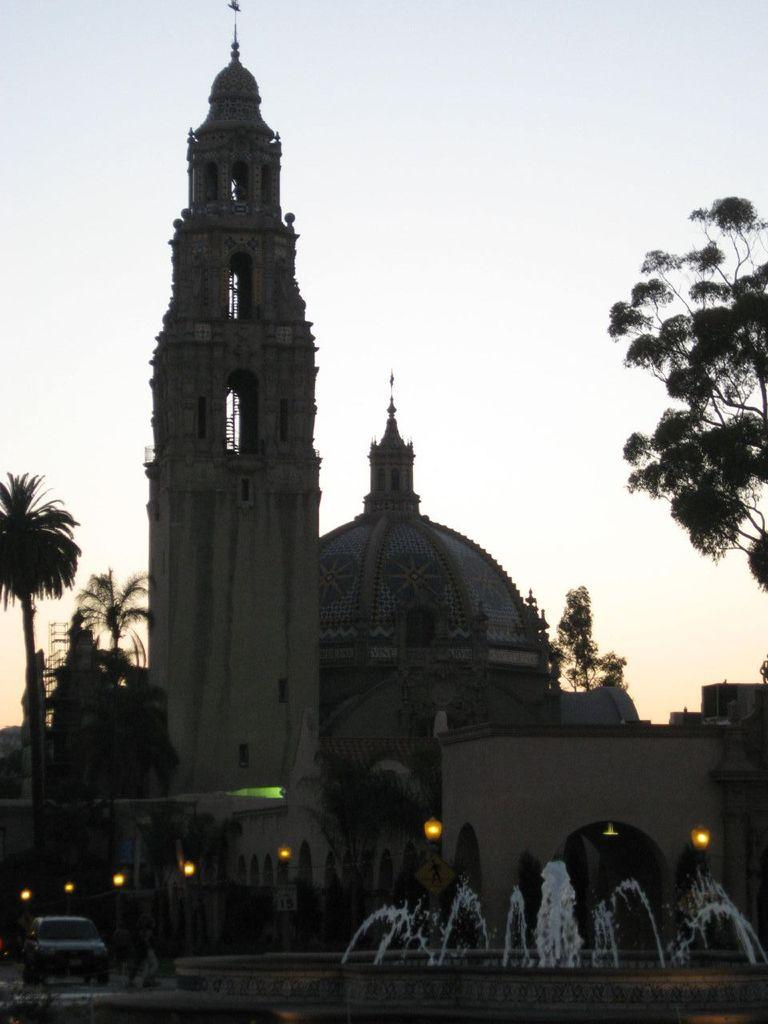What type of structures can be seen in the background of the image? There are buildings in the background of the image. What else is visible in front of the buildings? Vehicles are present in front of the buildings. What is the main feature in the middle of the image? There is a waterfall in the middle of the image. What can be seen above the waterfall? The sky is visible above the waterfall. What type of vegetation is present on either side of the waterfall? Trees are present on either side of the waterfall. What type of drain is visible near the waterfall in the image? There is no drain visible near the waterfall in the image. Who is the partner of the person standing next to the waterfall in the image? There is no person standing next to the waterfall in the image. How many knots are tied on the tree branches near the waterfall in the image? There are no knots tied on the tree branches near the waterfall in the image. 